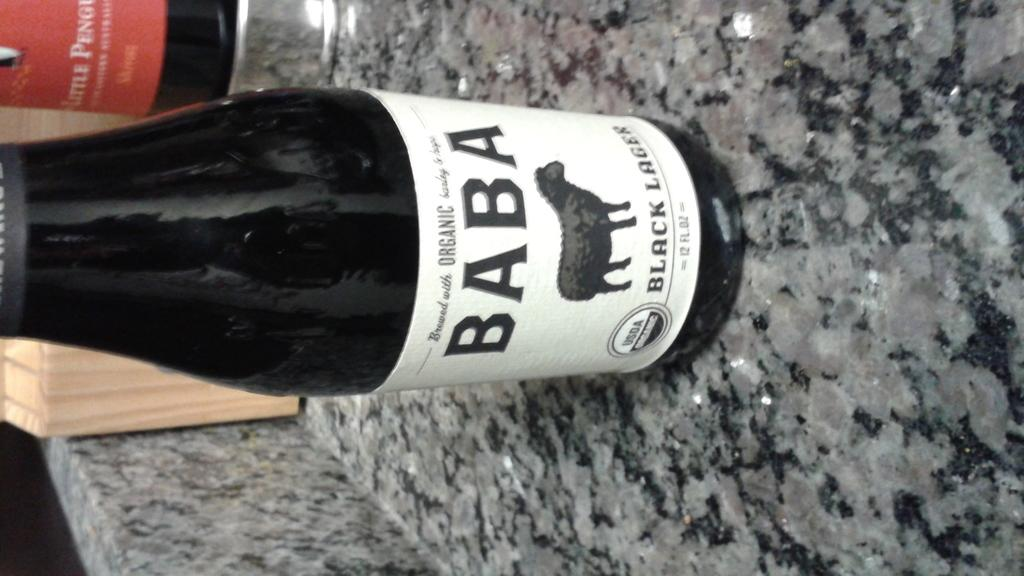<image>
Describe the image concisely. A bottle of BABA BLACK LAGER Brewed with Organic Barley & Hops is shown. 